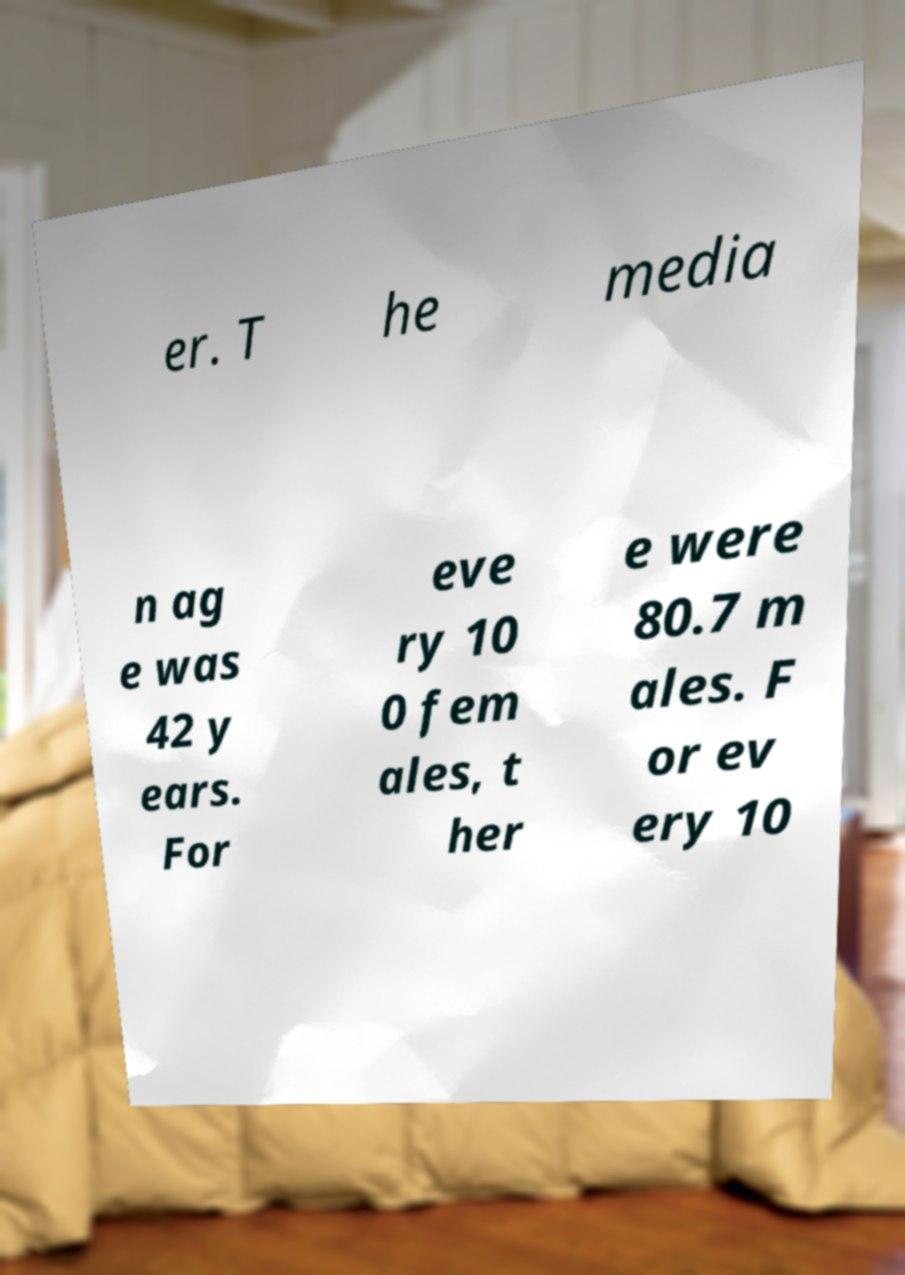Please identify and transcribe the text found in this image. er. T he media n ag e was 42 y ears. For eve ry 10 0 fem ales, t her e were 80.7 m ales. F or ev ery 10 